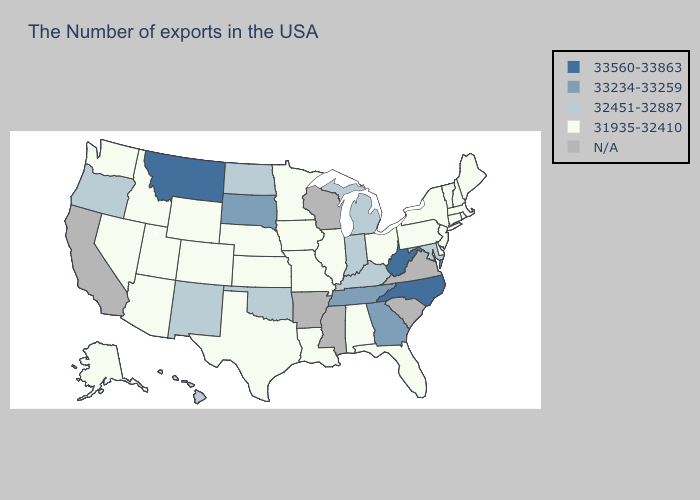Does Oregon have the lowest value in the West?
Be succinct. No. Does the first symbol in the legend represent the smallest category?
Keep it brief. No. Does the first symbol in the legend represent the smallest category?
Keep it brief. No. Among the states that border Mississippi , which have the lowest value?
Quick response, please. Alabama, Louisiana. What is the value of Iowa?
Keep it brief. 31935-32410. Is the legend a continuous bar?
Write a very short answer. No. What is the lowest value in the USA?
Quick response, please. 31935-32410. Does the map have missing data?
Write a very short answer. Yes. Name the states that have a value in the range 32451-32887?
Be succinct. Maryland, Michigan, Kentucky, Indiana, Oklahoma, North Dakota, New Mexico, Oregon, Hawaii. What is the value of Idaho?
Write a very short answer. 31935-32410. What is the lowest value in states that border Delaware?
Answer briefly. 31935-32410. Name the states that have a value in the range 31935-32410?
Be succinct. Maine, Massachusetts, Rhode Island, New Hampshire, Vermont, Connecticut, New York, New Jersey, Delaware, Pennsylvania, Ohio, Florida, Alabama, Illinois, Louisiana, Missouri, Minnesota, Iowa, Kansas, Nebraska, Texas, Wyoming, Colorado, Utah, Arizona, Idaho, Nevada, Washington, Alaska. What is the lowest value in states that border Arkansas?
Be succinct. 31935-32410. 